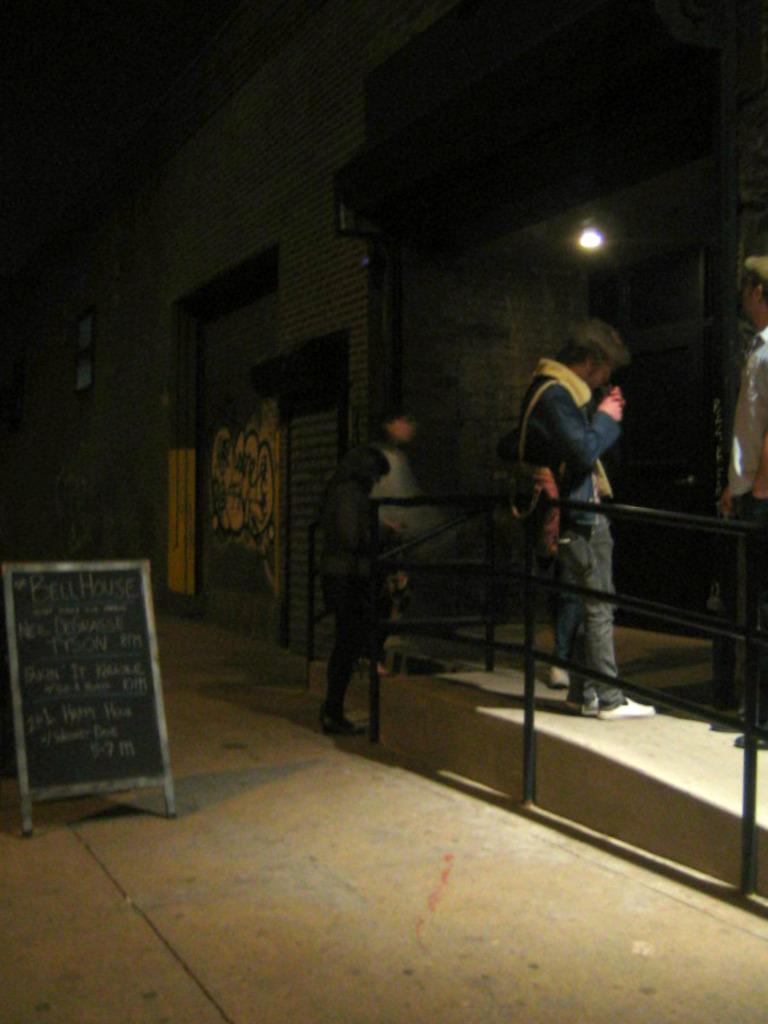Please provide a concise description of this image. There are three persons. Here we can see a fence, board, light, and a wall. 